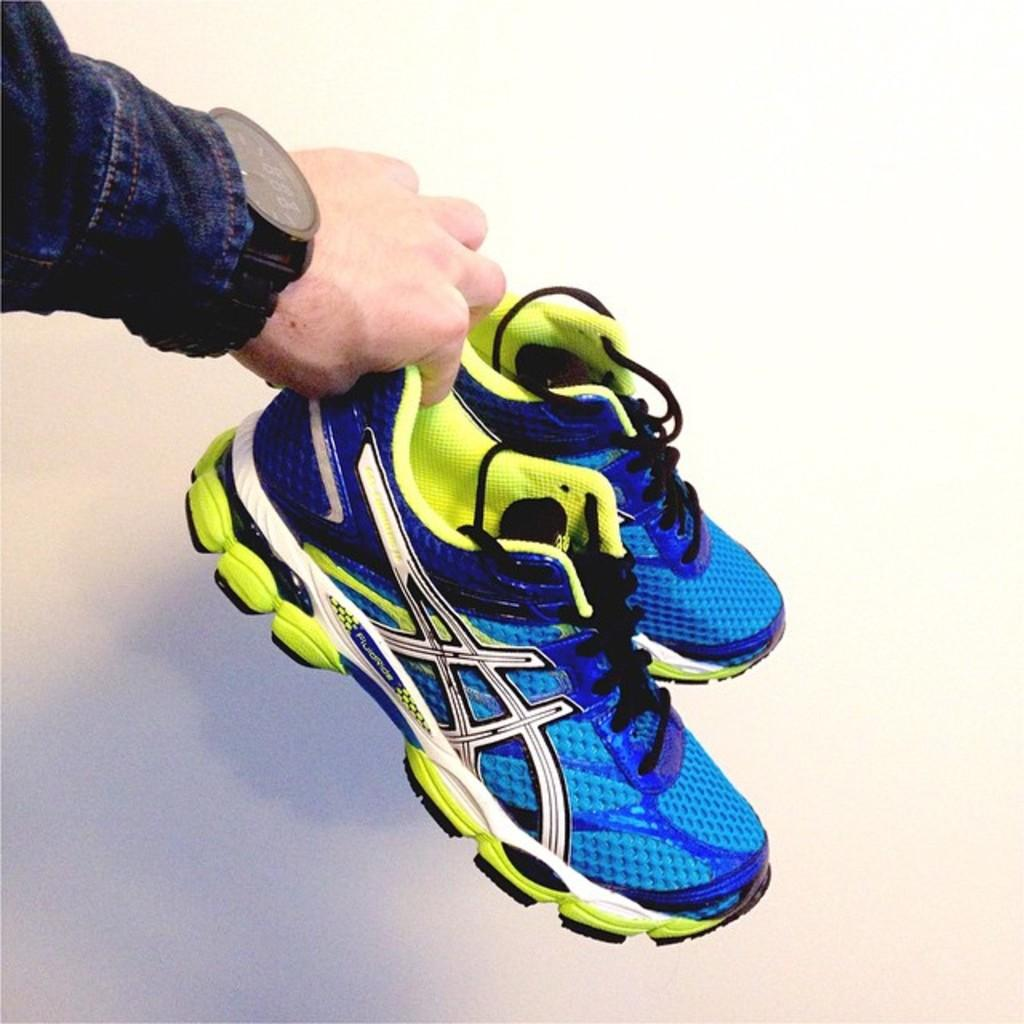What is the person's hand holding in the image? The person's hand is holding shoes in the image. What can be seen in the background of the image? There is a wall in the background of the image. What type of lunch is being prepared on the wall in the image? There is no lunch or any indication of food preparation in the image; it only shows a person's hand holding shoes and a wall in the background. 